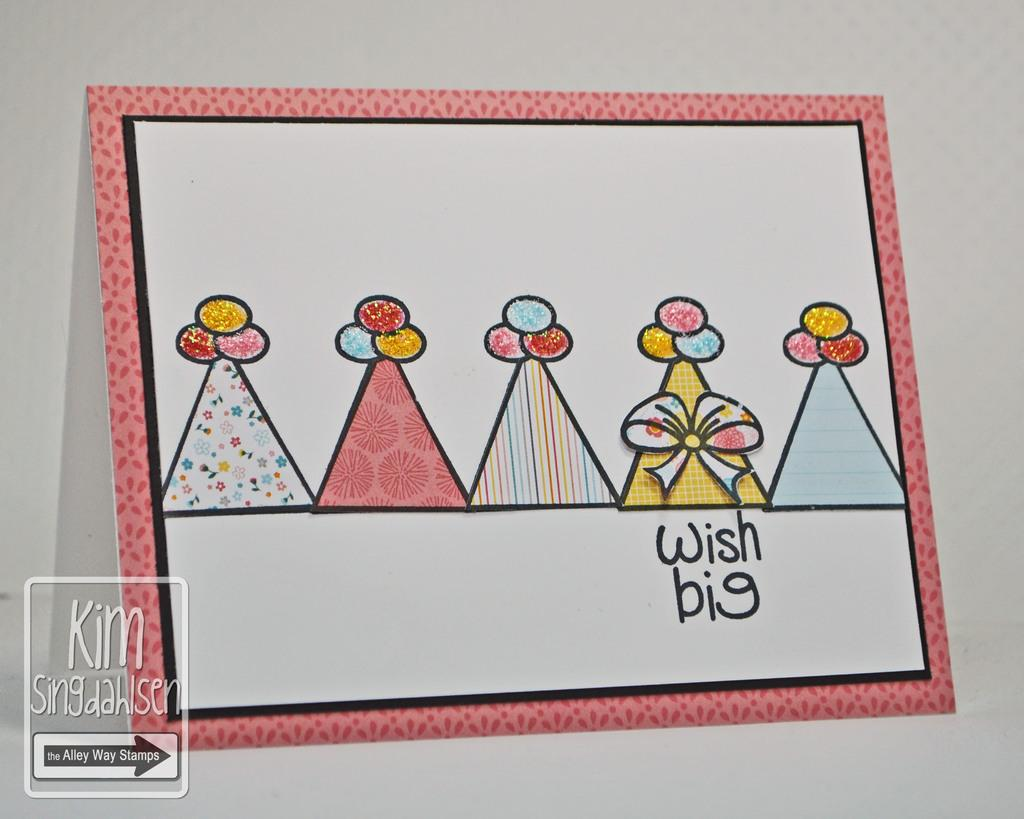<image>
Describe the image concisely. A drawing of colorful party hats and the words wish big written beneath them. 